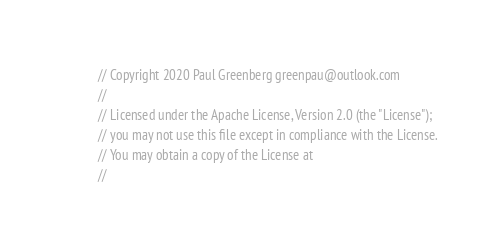Convert code to text. <code><loc_0><loc_0><loc_500><loc_500><_Go_>// Copyright 2020 Paul Greenberg greenpau@outlook.com
//
// Licensed under the Apache License, Version 2.0 (the "License");
// you may not use this file except in compliance with the License.
// You may obtain a copy of the License at
//</code> 